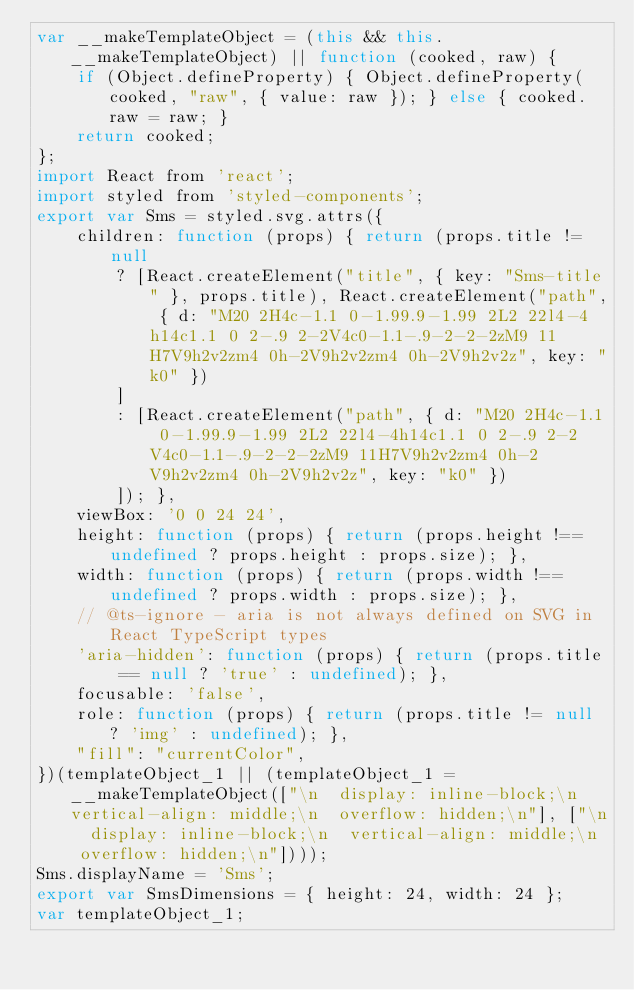Convert code to text. <code><loc_0><loc_0><loc_500><loc_500><_JavaScript_>var __makeTemplateObject = (this && this.__makeTemplateObject) || function (cooked, raw) {
    if (Object.defineProperty) { Object.defineProperty(cooked, "raw", { value: raw }); } else { cooked.raw = raw; }
    return cooked;
};
import React from 'react';
import styled from 'styled-components';
export var Sms = styled.svg.attrs({
    children: function (props) { return (props.title != null
        ? [React.createElement("title", { key: "Sms-title" }, props.title), React.createElement("path", { d: "M20 2H4c-1.1 0-1.99.9-1.99 2L2 22l4-4h14c1.1 0 2-.9 2-2V4c0-1.1-.9-2-2-2zM9 11H7V9h2v2zm4 0h-2V9h2v2zm4 0h-2V9h2v2z", key: "k0" })
        ]
        : [React.createElement("path", { d: "M20 2H4c-1.1 0-1.99.9-1.99 2L2 22l4-4h14c1.1 0 2-.9 2-2V4c0-1.1-.9-2-2-2zM9 11H7V9h2v2zm4 0h-2V9h2v2zm4 0h-2V9h2v2z", key: "k0" })
        ]); },
    viewBox: '0 0 24 24',
    height: function (props) { return (props.height !== undefined ? props.height : props.size); },
    width: function (props) { return (props.width !== undefined ? props.width : props.size); },
    // @ts-ignore - aria is not always defined on SVG in React TypeScript types
    'aria-hidden': function (props) { return (props.title == null ? 'true' : undefined); },
    focusable: 'false',
    role: function (props) { return (props.title != null ? 'img' : undefined); },
    "fill": "currentColor",
})(templateObject_1 || (templateObject_1 = __makeTemplateObject(["\n  display: inline-block;\n  vertical-align: middle;\n  overflow: hidden;\n"], ["\n  display: inline-block;\n  vertical-align: middle;\n  overflow: hidden;\n"])));
Sms.displayName = 'Sms';
export var SmsDimensions = { height: 24, width: 24 };
var templateObject_1;
</code> 